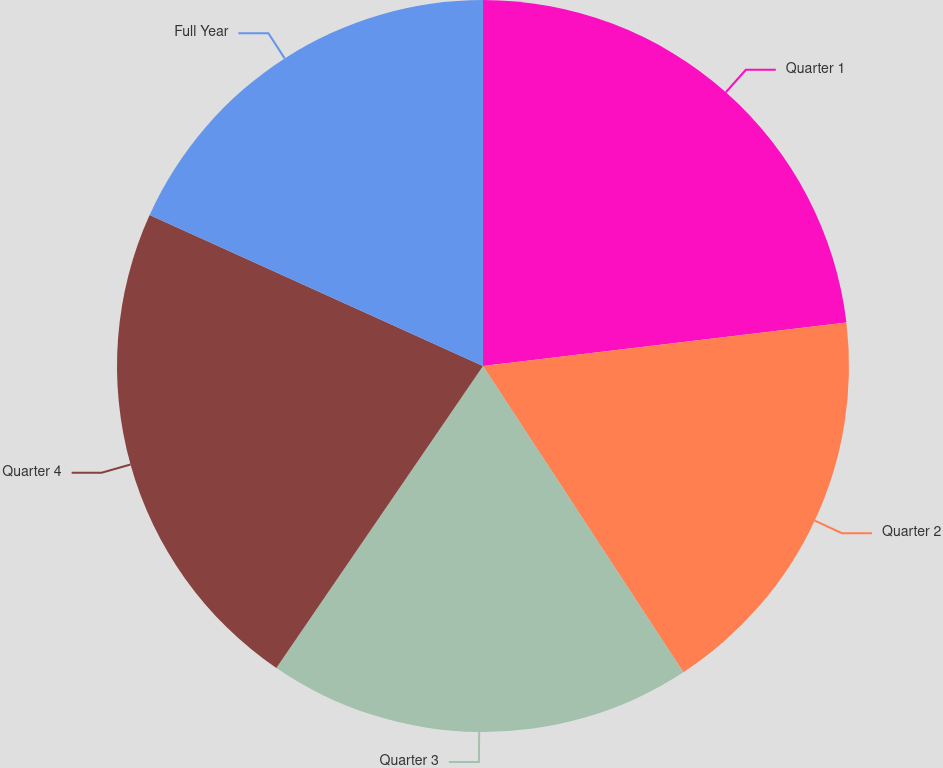Convert chart to OTSL. <chart><loc_0><loc_0><loc_500><loc_500><pie_chart><fcel>Quarter 1<fcel>Quarter 2<fcel>Quarter 3<fcel>Quarter 4<fcel>Full Year<nl><fcel>23.1%<fcel>17.68%<fcel>18.77%<fcel>22.22%<fcel>18.23%<nl></chart> 